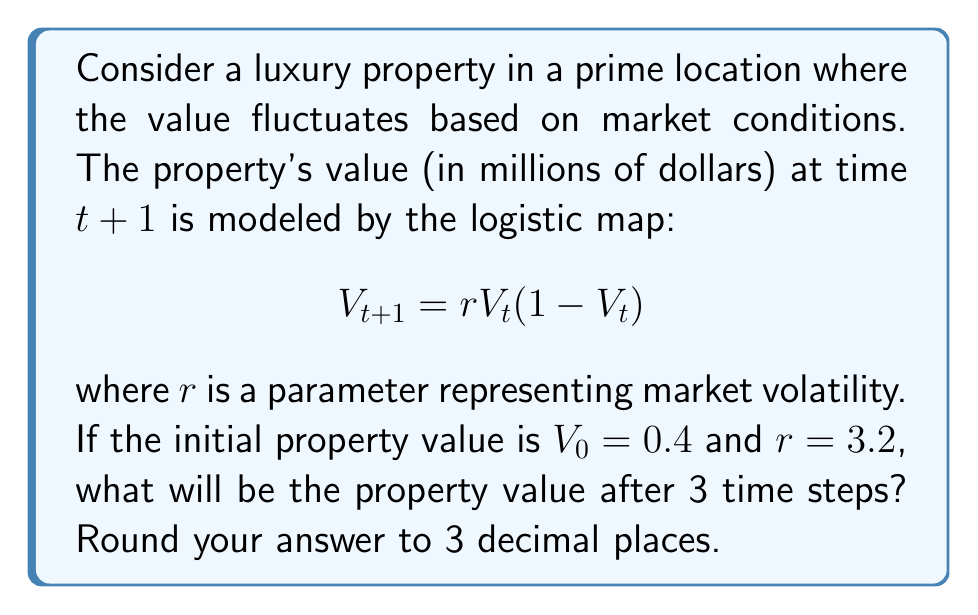Help me with this question. Let's solve this step-by-step:

1) We start with the given logistic map equation:
   $$V_{t+1} = rV_t(1-V_t)$$

2) We're given that $r = 3.2$ and $V_0 = 0.4$

3) Let's calculate $V_1$:
   $$V_1 = 3.2 \cdot 0.4 \cdot (1-0.4) = 3.2 \cdot 0.4 \cdot 0.6 = 0.768$$

4) Now let's calculate $V_2$:
   $$V_2 = 3.2 \cdot 0.768 \cdot (1-0.768) = 3.2 \cdot 0.768 \cdot 0.232 = 0.570$$

5) Finally, let's calculate $V_3$:
   $$V_3 = 3.2 \cdot 0.570 \cdot (1-0.570) = 3.2 \cdot 0.570 \cdot 0.430 = 0.784$$

6) Rounding to 3 decimal places, we get 0.784.

This value represents the property value in millions of dollars after 3 time steps.
Answer: $0.784$ million 